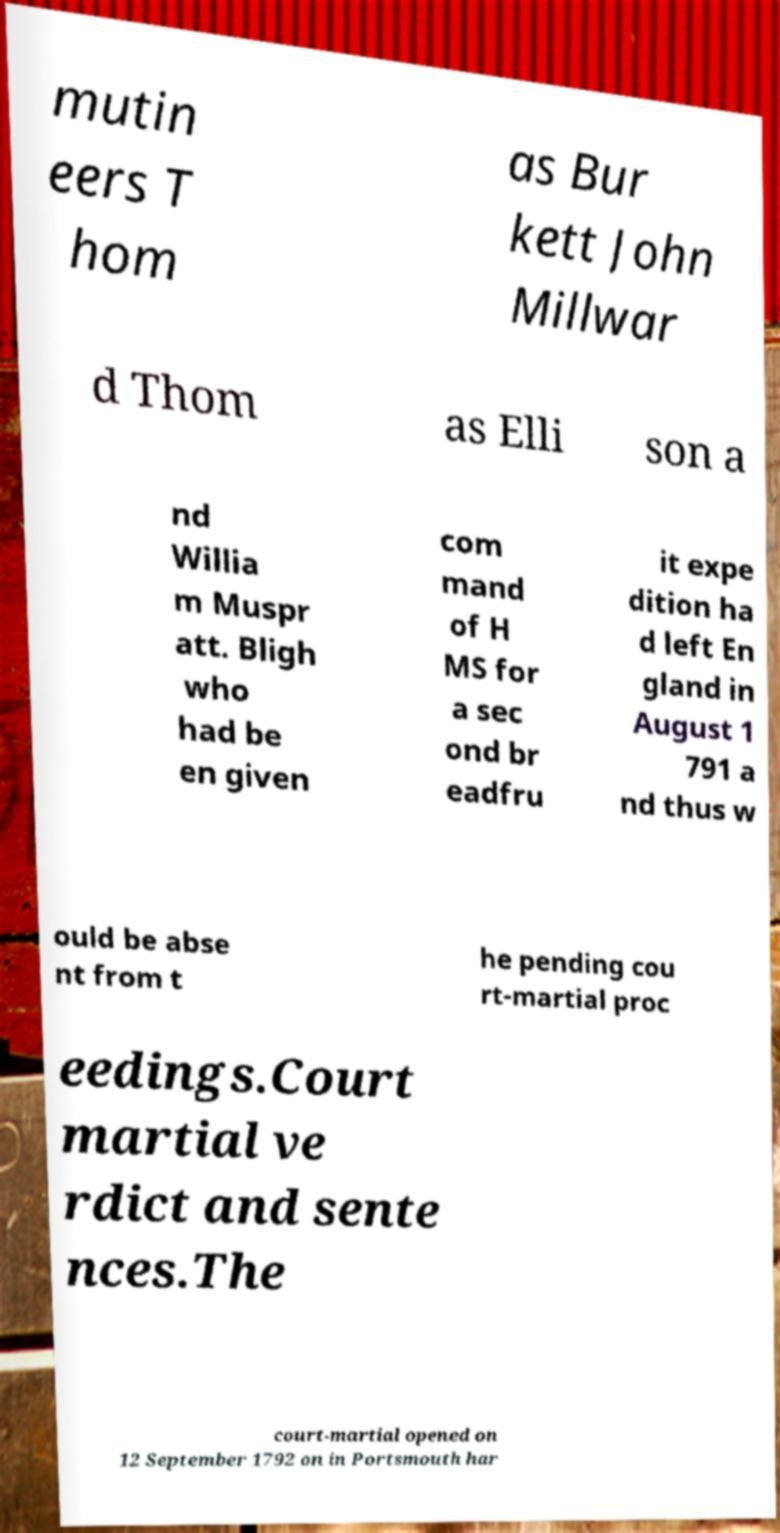Please identify and transcribe the text found in this image. mutin eers T hom as Bur kett John Millwar d Thom as Elli son a nd Willia m Muspr att. Bligh who had be en given com mand of H MS for a sec ond br eadfru it expe dition ha d left En gland in August 1 791 a nd thus w ould be abse nt from t he pending cou rt-martial proc eedings.Court martial ve rdict and sente nces.The court-martial opened on 12 September 1792 on in Portsmouth har 